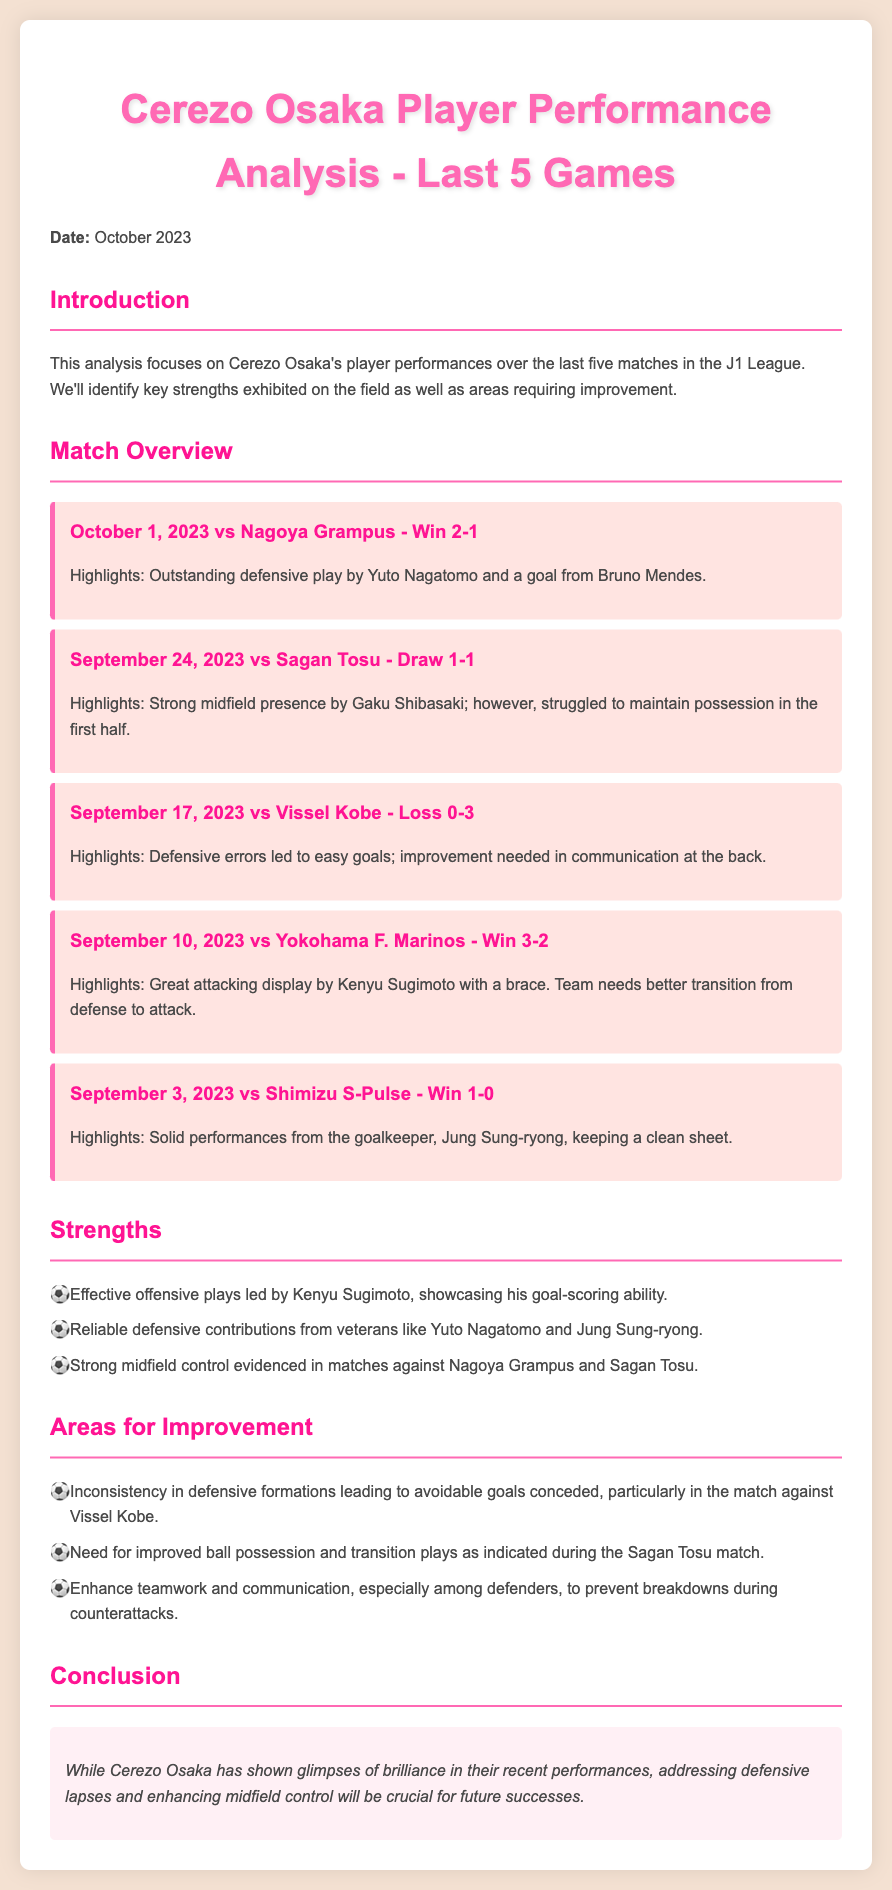What was the score against Nagoya Grampus? The score of the match against Nagoya Grampus on October 1, 2023, is mentioned in the document as 2-1.
Answer: 2-1 Who scored during the match against Vissel Kobe? The document does not specify any player scoring during the loss against Vissel Kobe, indicating it was a 0-3 defeat.
Answer: No one Which player provided a strong midfield presence against Sagan Tosu? Gaku Shibasaki is highlighted for his strong midfield presence in the draw against Sagan Tosu.
Answer: Gaku Shibasaki How many wins did Cerezo Osaka have in the last five games? The document provides match outcomes and counts the total wins. Cerezo Osaka won three matches out of five.
Answer: 3 What area for improvement is mentioned regarding defensive formations? The document indicates inconsistency in defensive formations leading to avoidable goals as an area for improvement after the match against Vissel Kobe.
Answer: Inconsistency Which player had a brace against Yokohama F. Marinos? Kenyu Sugimoto's performance is highlighted for scoring two goals (a brace) in the match against Yokohama F. Marinos.
Answer: Kenyu Sugimoto What is the significance of Jung Sung-ryong in the last five games? The document states that Jung Sung-ryong had a solid performance as a goalkeeper, keeping a clean sheet in the match against Shimizu S-Pulse.
Answer: Clean sheet What does the conclusion suggest is crucial for future successes? The conclusion emphasizes that addressing defensive lapses and enhancing midfield control will be crucial for Cerezo Osaka’s future successes.
Answer: Defensive lapses and midfield control Which match resulted in a draw? The document explicitly states that the match against Sagan Tosu ended in a draw with a score of 1-1.
Answer: Sagan Tosu 